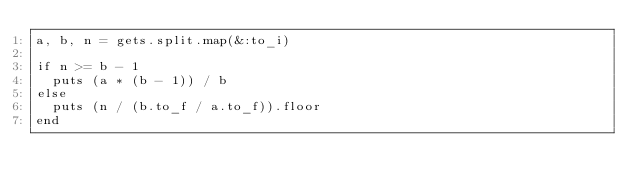Convert code to text. <code><loc_0><loc_0><loc_500><loc_500><_Ruby_>a, b, n = gets.split.map(&:to_i)

if n >= b - 1
  puts (a * (b - 1)) / b
else
  puts (n / (b.to_f / a.to_f)).floor
end</code> 